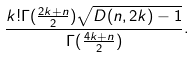Convert formula to latex. <formula><loc_0><loc_0><loc_500><loc_500>\frac { k ! \Gamma ( \frac { 2 k + n } { 2 } ) \sqrt { D ( n , 2 k ) - 1 } } { \Gamma ( \frac { 4 k + n } { 2 } ) } .</formula> 